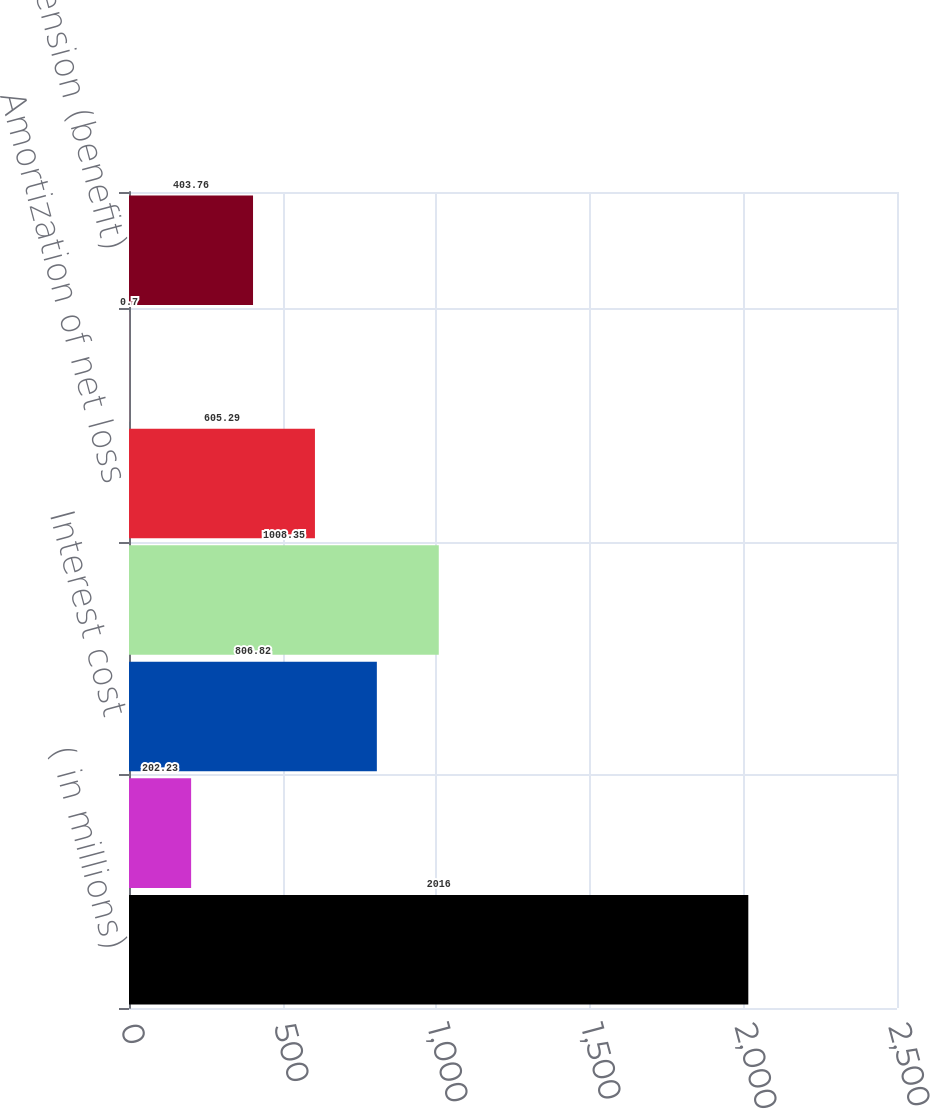Convert chart to OTSL. <chart><loc_0><loc_0><loc_500><loc_500><bar_chart><fcel>( in millions)<fcel>Service cost<fcel>Interest cost<fcel>Expected return on plan assets<fcel>Amortization of net loss<fcel>Curtailment and settlement<fcel>Net periodic pension (benefit)<nl><fcel>2016<fcel>202.23<fcel>806.82<fcel>1008.35<fcel>605.29<fcel>0.7<fcel>403.76<nl></chart> 